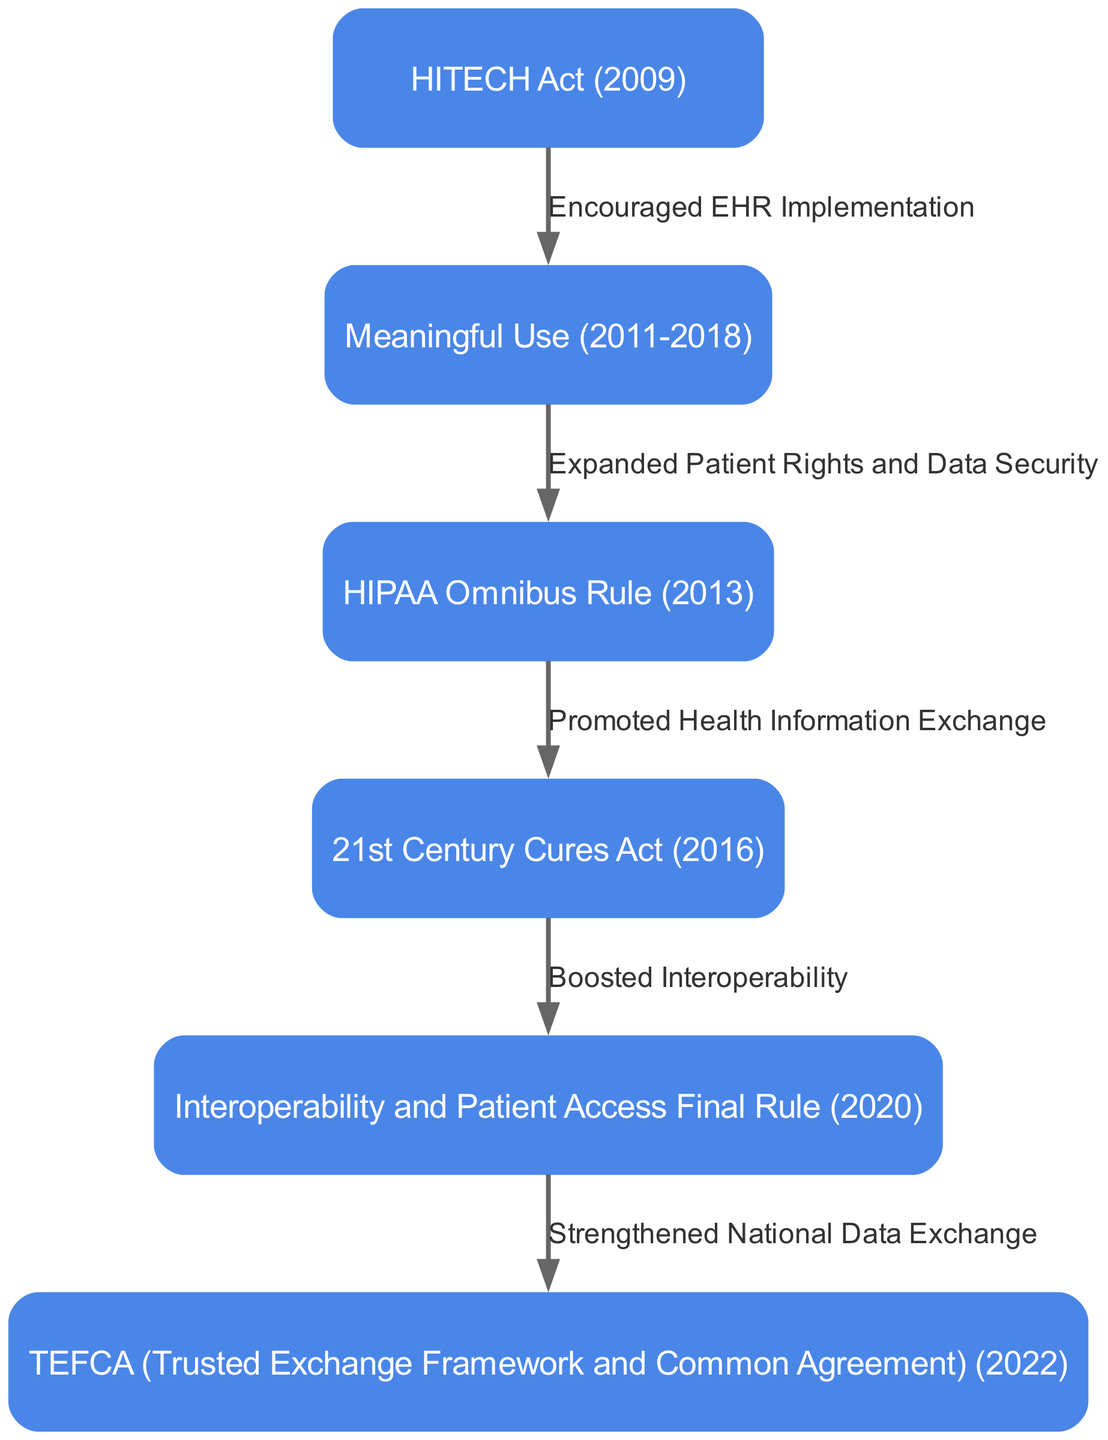What is the first regulation in the diagram? The diagram starts with the node labeled "HITECH Act (2009)" as the first regulation.
Answer: HITECH Act (2009) How many nodes are present in the diagram? The diagram lists six distinct regulations, each represented by a node.
Answer: 6 What does the edge from "21st Century Cures Act (2016)" to "Interoperability and Patient Access Final Rule (2020)" indicate? The edge indicates that the 21st Century Cures Act promoted health information exchange, leading to the development of the Interoperability and Patient Access Final Rule.
Answer: Promoted health information exchange Which node represents a regulation that strengthened national data exchange? The last node, "TEFCA (Trusted Exchange Framework and Common Agreement) (2022)", represents regulation focused on strengthening national data exchange.
Answer: TEFCA (Trusted Exchange Framework and Common Agreement) (2022) What relationship is indicated between "Meaningful Use (2011-2018)" and "HIPAA Omnibus Rule (2013)"? The edge indicates that the implementation of Meaningful Use expanded patient rights and data security through the HIPAA Omnibus Rule.
Answer: Expanded patient rights and data security What was the main impact of the HITECH Act (2009) as indicated in the diagram? The diagram shows that the HITECH Act encouraged the implementation of Electronic Health Records (EHR).
Answer: Encouraged EHR implementation What is the significance of the edge leading from "Interoperability and Patient Access Final Rule (2020)" to "TEFCA (2022)"? This edge signifies that the Interoperability and Patient Access Final Rule strengthened the national data exchange framework, paving the way for TEFCA.
Answer: Strengthened national data exchange Which regulation boosted interoperability in healthcare IT systems? The regulation indicated in the diagram that boosted interoperability is the "21st Century Cures Act (2016)".
Answer: 21st Century Cures Act (2016) 